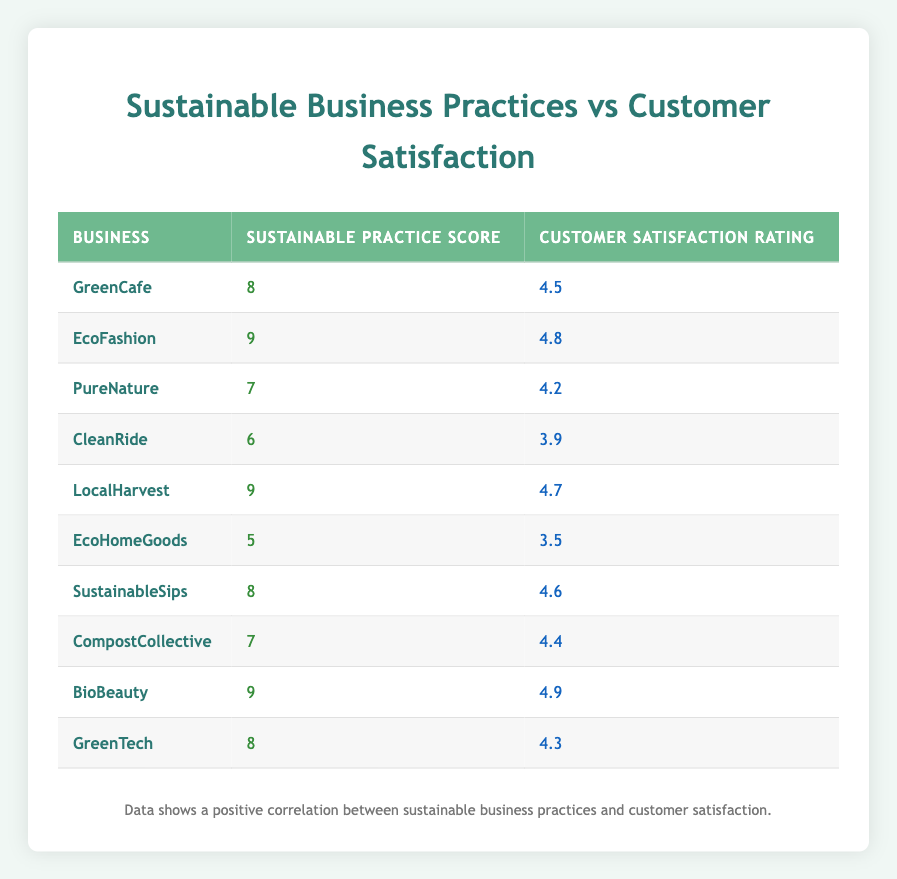What is the customer satisfaction rating of EcoFashion? The table shows the customer satisfaction rating for EcoFashion is listed next to its sustainable practice score. From the table, EcoFashion has a customer satisfaction rating of 4.8.
Answer: 4.8 Which business has the highest sustainable practice score? To find the highest sustainable practice score, we look across the 'Sustainable Practice Score' column. The maximum score of 9 appears three times for EcoFashion, LocalHarvest, and BioBeauty.
Answer: EcoFashion, LocalHarvest, and BioBeauty What is the average customer satisfaction rating for businesses with a sustainable practice score of 8? The businesses with a sustainable practice score of 8 are GreenCafe, SustainableSips, and GreenTech. Their customer satisfaction ratings are 4.5, 4.6, and 4.3 respectively. Summing these ratings gives 4.5 + 4.6 + 4.3 = 13.4. The average is 13.4 / 3 = 4.47.
Answer: 4.47 Is the customer satisfaction rating for CleanRide greater than 4? Looking at the customer satisfaction rating for CleanRide, it is 3.9, which is less than 4.
Answer: No Which business has the lowest customer satisfaction rating, and what is it? To answer, we compare all customer satisfaction ratings in the table. CleanRide’s satisfaction rating of 3.9 is the lowest.
Answer: CleanRide, 3.9 If we increase the sustainable practice score of EcoHomeGoods by 2, what would its new sustainable practice score be? EcoHomeGoods currently has a sustainable practice score of 5. If we increase it by 2, we calculate 5 + 2 which equals 7.
Answer: 7 Which businesses have a customer satisfaction rating greater than 4.5? We check each business's customer satisfaction rating and identify those above 4.5. Businesses are EcoFashion (4.8), LocalHarvest (4.7), BioBeauty (4.9), and SustainableSips (4.6).
Answer: EcoFashion, LocalHarvest, BioBeauty, SustainableSips Is there a clear trend suggesting higher sustainable practice scores correlate with higher customer satisfaction ratings? A visual examination of the scores shows that as the sustainable practice scores increase, the customer satisfaction ratings also tend to be higher. For example, businesses with a score of 9 have ratings of 4.8, 4.7, and 4.9. Thus, there is a positive correlation.
Answer: Yes 